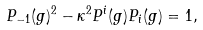Convert formula to latex. <formula><loc_0><loc_0><loc_500><loc_500>P _ { - 1 } ( g ) ^ { 2 } - \kappa ^ { 2 } P ^ { i } ( g ) P _ { i } ( g ) = 1 ,</formula> 